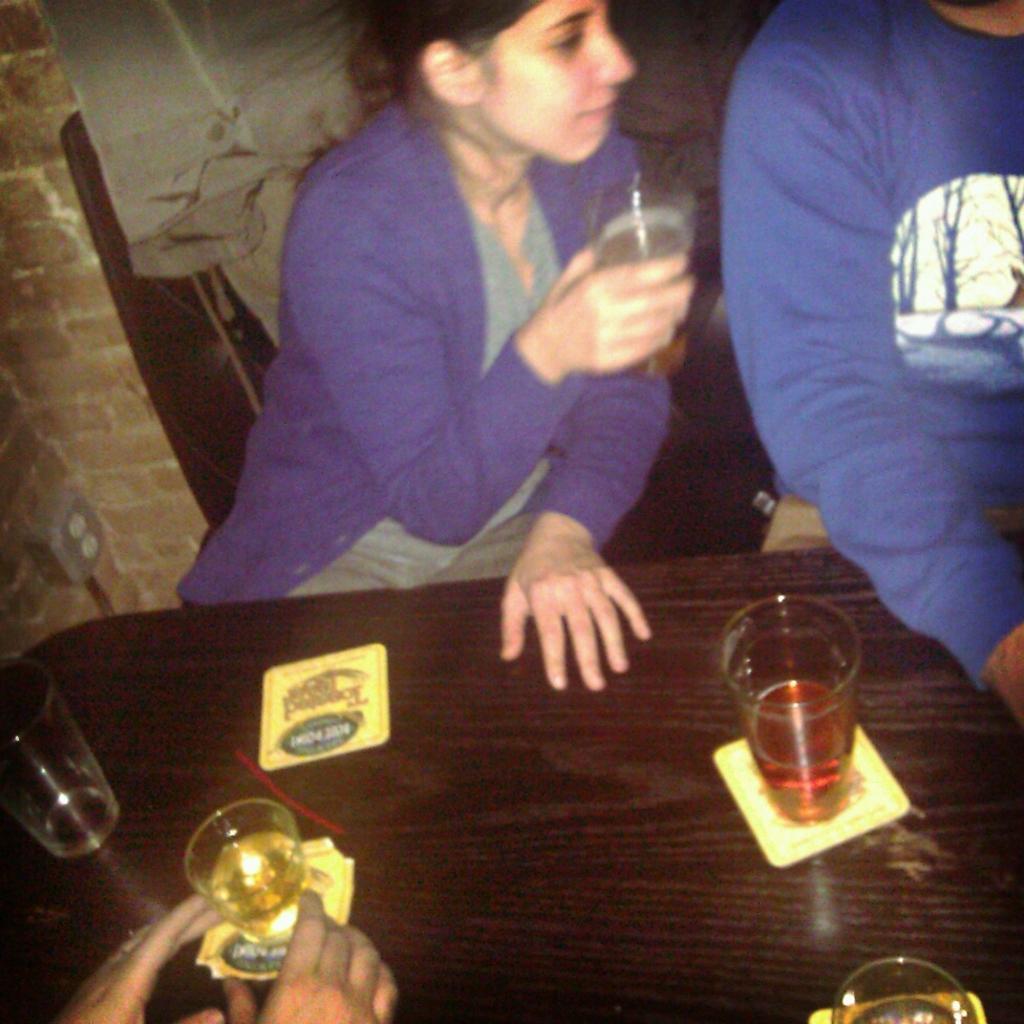Describe this image in one or two sentences. In the center of the image we can see people sitting and holding glasses in their hands, before them there is a table and we can see glasses and paper placed on the table. In the background there is a wall. 